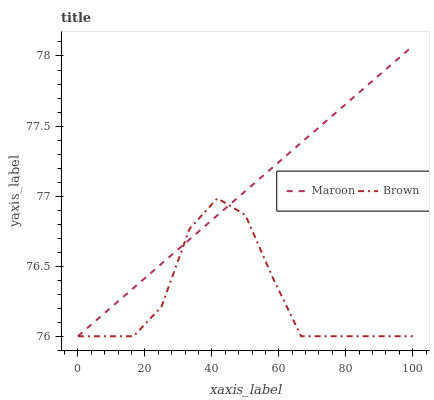Does Maroon have the minimum area under the curve?
Answer yes or no. No. Is Maroon the roughest?
Answer yes or no. No. 